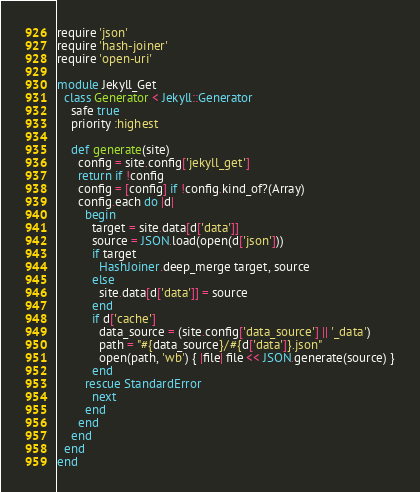Convert code to text. <code><loc_0><loc_0><loc_500><loc_500><_Ruby_>require 'json'
require 'hash-joiner'
require 'open-uri'

module Jekyll_Get
  class Generator < Jekyll::Generator
    safe true
    priority :highest

    def generate(site)
      config = site.config['jekyll_get']
      return if !config
      config = [config] if !config.kind_of?(Array)
      config.each do |d|
        begin
          target = site.data[d['data']]
          source = JSON.load(open(d['json']))
          if target
            HashJoiner.deep_merge target, source
          else
            site.data[d['data']] = source
          end
          if d['cache']
            data_source = (site.config['data_source'] || '_data')
            path = "#{data_source}/#{d['data']}.json"
            open(path, 'wb') { |file| file << JSON.generate(source) }
          end
        rescue StandardError
          next
        end
      end
    end
  end
end
</code> 